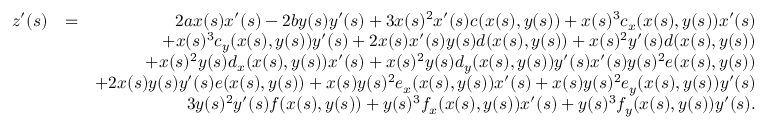Convert formula to latex. <formula><loc_0><loc_0><loc_500><loc_500>\begin{array} { r l r } { z ^ { \prime } ( s ) } & { = } & { 2 a x ( s ) x ^ { \prime } ( s ) - 2 b y ( s ) y ^ { \prime } ( s ) + 3 x ( s ) ^ { 2 } x ^ { \prime } ( s ) c ( x ( s ) , y ( s ) ) + x ( s ) ^ { 3 } c _ { x } ( x ( s ) , y ( s ) ) x ^ { \prime } ( s ) } \\ & { + x ( s ) ^ { 3 } c _ { y } ( x ( s ) , y ( s ) ) y ^ { \prime } ( s ) + 2 x ( s ) x ^ { \prime } ( s ) y ( s ) d ( x ( s ) , y ( s ) ) + x ( s ) ^ { 2 } y ^ { \prime } ( s ) d ( x ( s ) , y ( s ) ) } \\ & { + x ( s ) ^ { 2 } y ( s ) d _ { x } ( x ( s ) , y ( s ) ) x ^ { \prime } ( s ) + x ( s ) ^ { 2 } y ( s ) d _ { y } ( x ( s ) , y ( s ) ) y ^ { \prime } ( s ) x ^ { \prime } ( s ) y ( s ) ^ { 2 } e ( x ( s ) , y ( s ) ) } \\ & { + 2 x ( s ) y ( s ) y ^ { \prime } ( s ) e ( x ( s ) , y ( s ) ) + x ( s ) y ( s ) ^ { 2 } e _ { x } ( x ( s ) , y ( s ) ) x ^ { \prime } ( s ) + x ( s ) y ( s ) ^ { 2 } e _ { y } ( x ( s ) , y ( s ) ) y ^ { \prime } ( s ) } \\ & { 3 y ( s ) ^ { 2 } y ^ { \prime } ( s ) f ( x ( s ) , y ( s ) ) + y ( s ) ^ { 3 } f _ { x } ( x ( s ) , y ( s ) ) x ^ { \prime } ( s ) + y ( s ) ^ { 3 } f _ { y } ( x ( s ) , y ( s ) ) y ^ { \prime } ( s ) . } \end{array}</formula> 